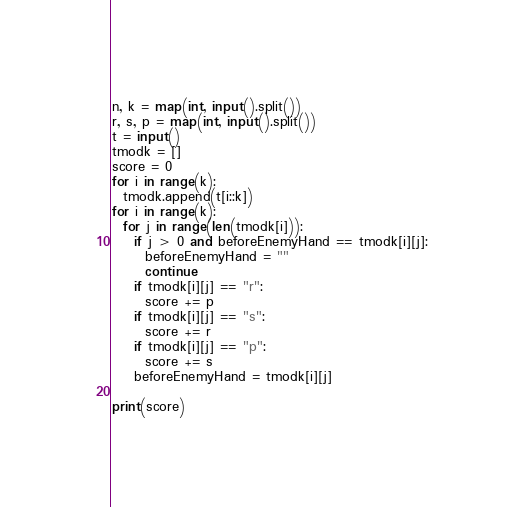Convert code to text. <code><loc_0><loc_0><loc_500><loc_500><_Python_>n, k = map(int, input().split())
r, s, p = map(int, input().split())
t = input()
tmodk = []
score = 0
for i in range(k):
  tmodk.append(t[i::k])
for i in range(k):
  for j in range(len(tmodk[i])):
    if j > 0 and beforeEnemyHand == tmodk[i][j]:
      beforeEnemyHand = ""
      continue
    if tmodk[i][j] == "r":
      score += p
    if tmodk[i][j] == "s":
      score += r
    if tmodk[i][j] == "p":
      score += s
    beforeEnemyHand = tmodk[i][j]
    
print(score)</code> 